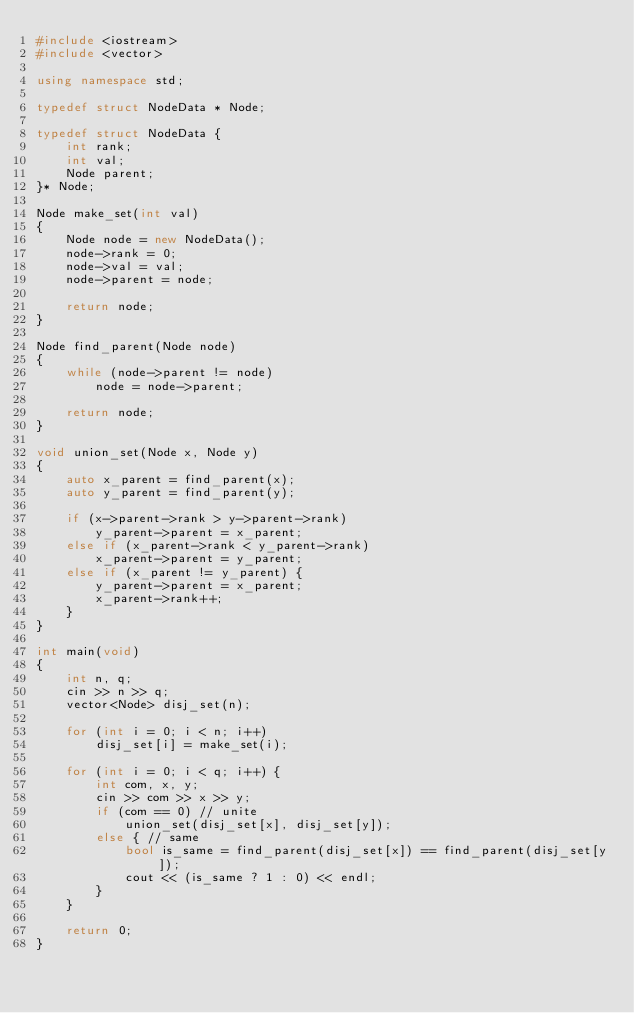Convert code to text. <code><loc_0><loc_0><loc_500><loc_500><_C++_>#include <iostream>
#include <vector>

using namespace std;

typedef struct NodeData * Node;

typedef struct NodeData {
    int rank;
    int val;
    Node parent;
}* Node;

Node make_set(int val)
{
    Node node = new NodeData();
    node->rank = 0;
    node->val = val;
    node->parent = node;

    return node;
}

Node find_parent(Node node)
{
    while (node->parent != node)
        node = node->parent;

    return node;
}

void union_set(Node x, Node y)
{
    auto x_parent = find_parent(x);
    auto y_parent = find_parent(y);

    if (x->parent->rank > y->parent->rank)
        y_parent->parent = x_parent;
    else if (x_parent->rank < y_parent->rank)
        x_parent->parent = y_parent;
    else if (x_parent != y_parent) {
        y_parent->parent = x_parent;
        x_parent->rank++;
    }
}

int main(void)
{
    int n, q;
    cin >> n >> q;
    vector<Node> disj_set(n);

    for (int i = 0; i < n; i++) 
        disj_set[i] = make_set(i);

    for (int i = 0; i < q; i++) {
        int com, x, y;
        cin >> com >> x >> y;
        if (com == 0) // unite
            union_set(disj_set[x], disj_set[y]);
        else { // same
            bool is_same = find_parent(disj_set[x]) == find_parent(disj_set[y]);
            cout << (is_same ? 1 : 0) << endl;
        }
    }
    
    return 0;
}</code> 